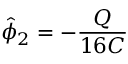Convert formula to latex. <formula><loc_0><loc_0><loc_500><loc_500>\hat { \phi } _ { 2 } = - \frac { Q } { 1 6 C }</formula> 